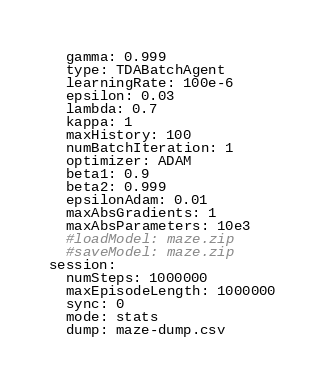<code> <loc_0><loc_0><loc_500><loc_500><_YAML_>  gamma: 0.999
  type: TDABatchAgent
  learningRate: 100e-6
  epsilon: 0.03
  lambda: 0.7
  kappa: 1
  maxHistory: 100
  numBatchIteration: 1
  optimizer: ADAM
  beta1: 0.9
  beta2: 0.999
  epsilonAdam: 0.01
  maxAbsGradients: 1
  maxAbsParameters: 10e3
  #loadModel: maze.zip
  #saveModel: maze.zip
session:
  numSteps: 1000000
  maxEpisodeLength: 1000000
  sync: 0
  mode: stats
  dump: maze-dump.csv
</code> 